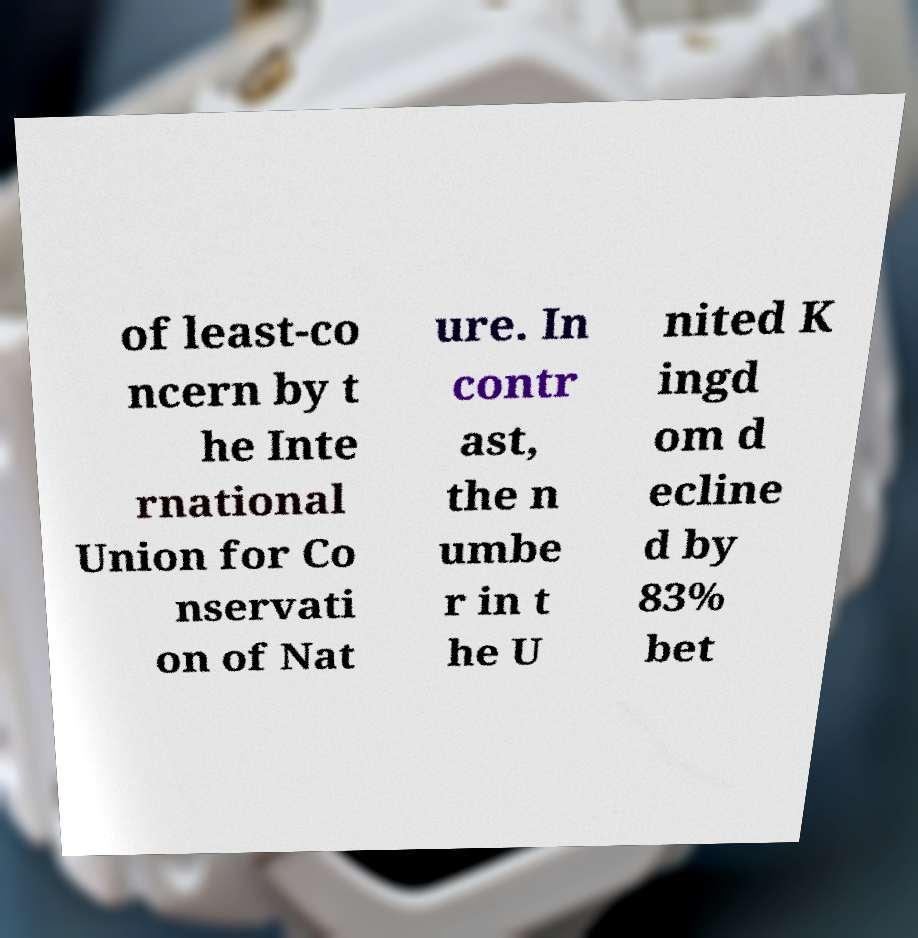What messages or text are displayed in this image? I need them in a readable, typed format. of least-co ncern by t he Inte rnational Union for Co nservati on of Nat ure. In contr ast, the n umbe r in t he U nited K ingd om d ecline d by 83% bet 